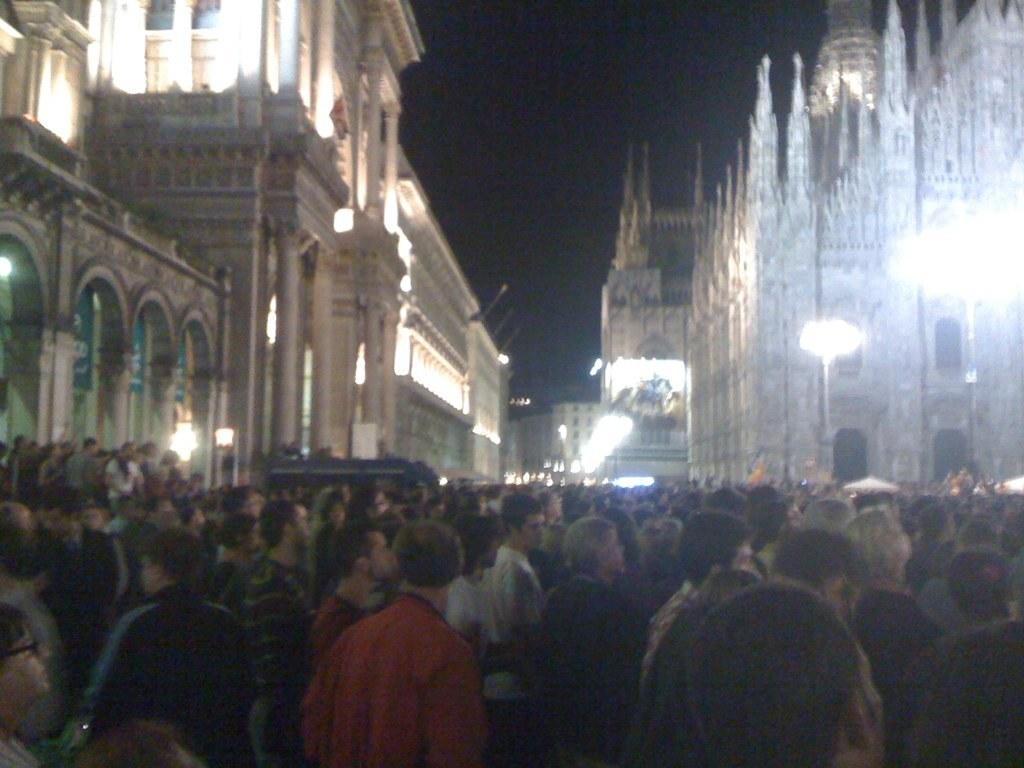What is happening on the road in the image? There is a crowd standing on the road in the image. What can be seen in the background of the image? There are buildings visible in the image. What type of infrastructure is present along the road? Street lights and street poles are visible in the image. What is visible above the crowd and buildings? The sky is visible in the image. How many girls are sitting on the squirrel in the image? There are no girls or squirrels present in the image. What type of country is depicted in the image? The image does not depict a specific country; it shows a crowd, buildings, street lights, street poles, and the sky. 